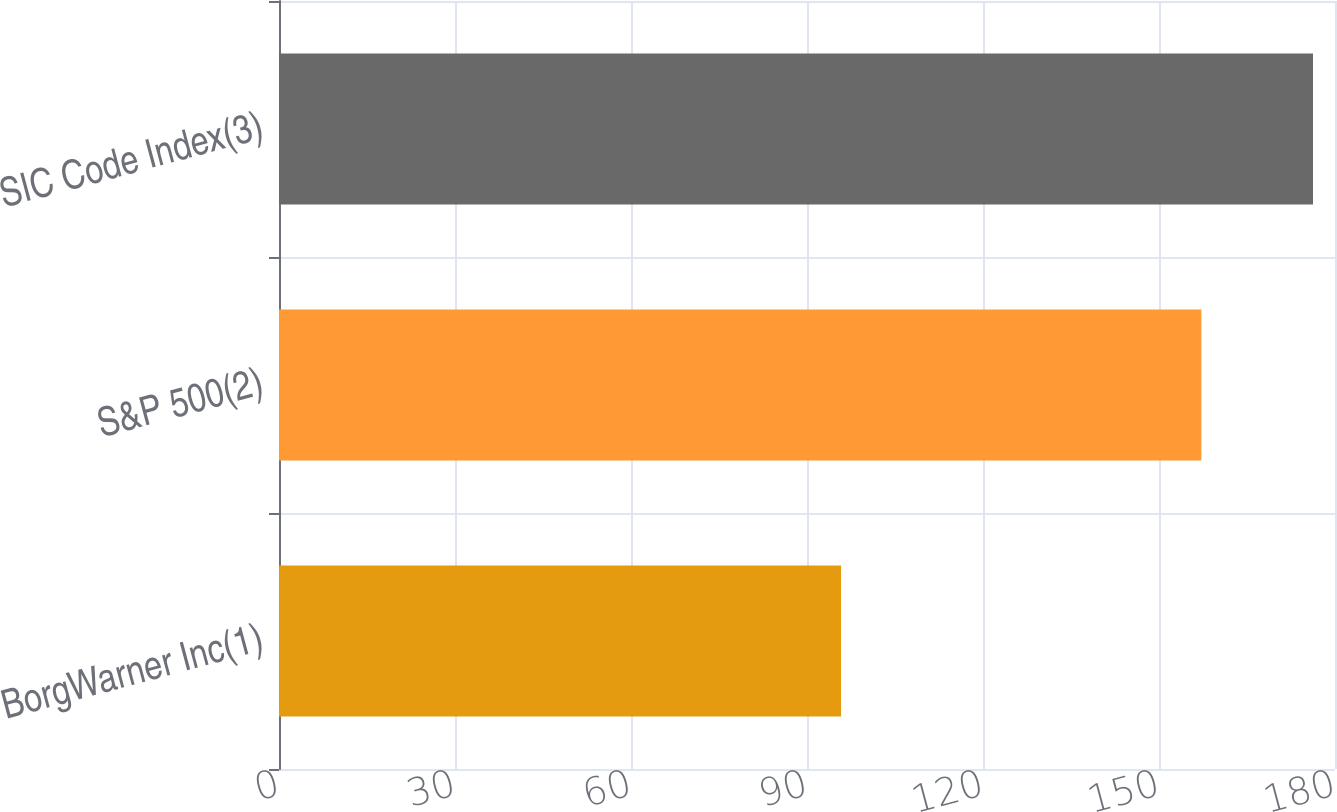<chart> <loc_0><loc_0><loc_500><loc_500><bar_chart><fcel>BorgWarner Inc(1)<fcel>S&P 500(2)<fcel>SIC Code Index(3)<nl><fcel>95.81<fcel>157.22<fcel>176.25<nl></chart> 